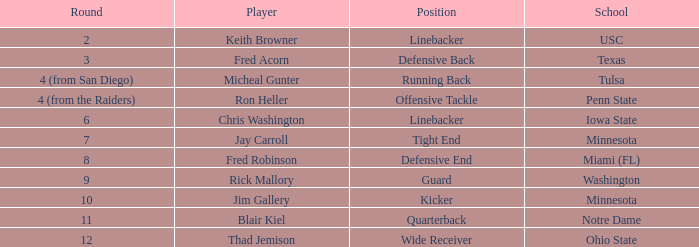What is Thad Jemison's position? Wide Receiver. 